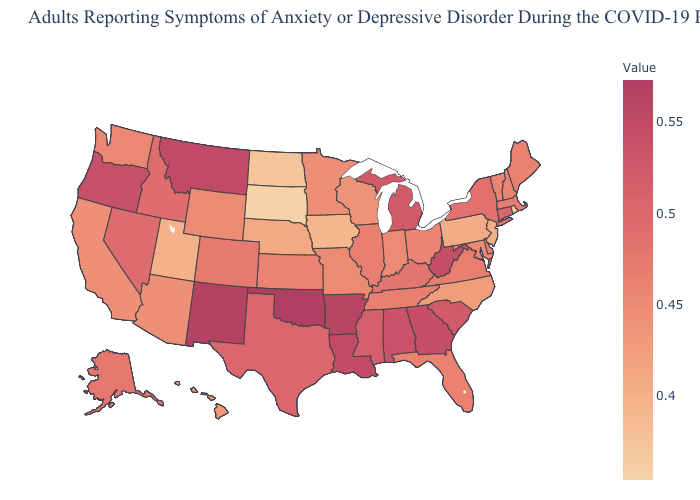Is the legend a continuous bar?
Give a very brief answer. Yes. Does the map have missing data?
Quick response, please. No. Is the legend a continuous bar?
Keep it brief. Yes. Does California have the lowest value in the USA?
Be succinct. No. Is the legend a continuous bar?
Give a very brief answer. Yes. Is the legend a continuous bar?
Quick response, please. Yes. Does Connecticut have the highest value in the USA?
Concise answer only. No. 